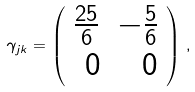<formula> <loc_0><loc_0><loc_500><loc_500>\gamma _ { j k } = \left ( \begin{array} { r r } \frac { 2 5 } { 6 } & - \frac { 5 } { 6 } \\ 0 & 0 \end{array} \right ) \, ,</formula> 